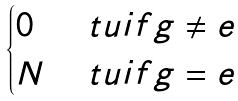Convert formula to latex. <formula><loc_0><loc_0><loc_500><loc_500>\begin{cases} 0 & \ t u { i f } g \neq e \\ N & \ t u { i f } g = e \end{cases}</formula> 